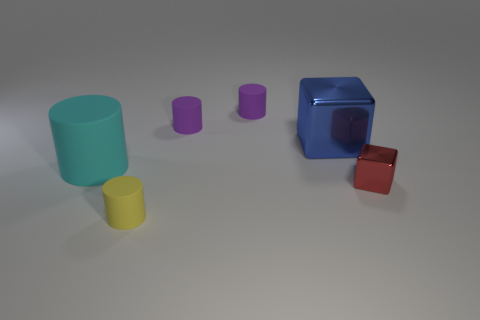Are there the same number of small metallic cubes that are in front of the yellow cylinder and small red cubes in front of the large cyan cylinder?
Keep it short and to the point. No. Is there a small purple object made of the same material as the small yellow cylinder?
Provide a succinct answer. Yes. Do the small cylinder in front of the big cyan cylinder and the large blue thing have the same material?
Ensure brevity in your answer.  No. There is a matte object that is in front of the large blue metal object and behind the red object; how big is it?
Your answer should be very brief. Large. What is the color of the small cube?
Make the answer very short. Red. What number of yellow rubber things are there?
Your answer should be compact. 1. How many big things are the same color as the tiny block?
Make the answer very short. 0. There is a metallic thing to the left of the red object; does it have the same shape as the metal thing that is in front of the big matte thing?
Offer a terse response. Yes. There is a large thing left of the small thing in front of the metallic thing in front of the large metal cube; what color is it?
Provide a succinct answer. Cyan. The metallic object behind the cyan matte thing is what color?
Your response must be concise. Blue. 